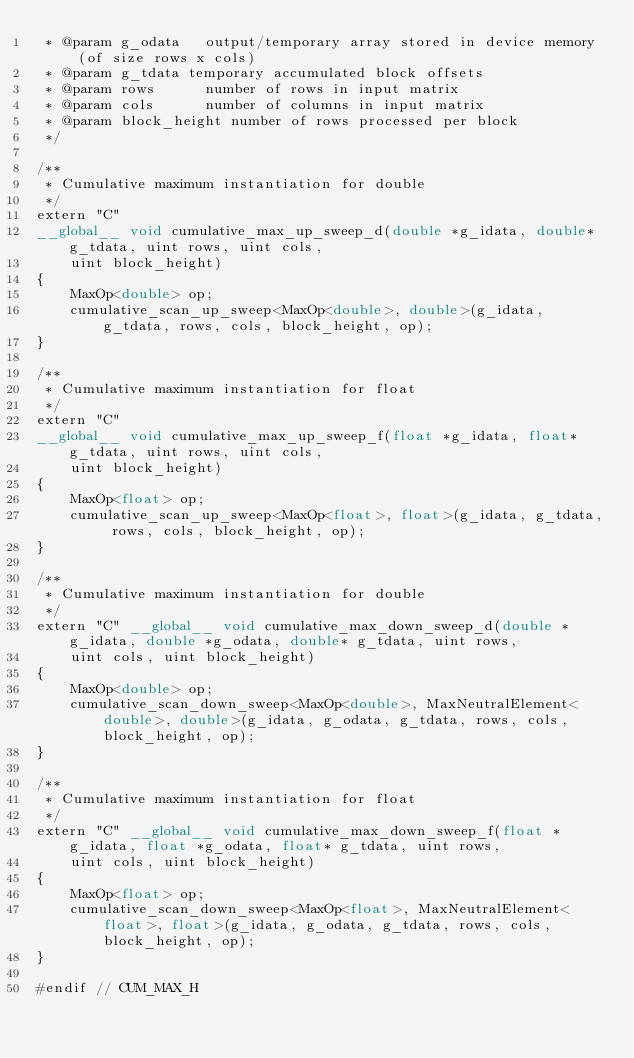Convert code to text. <code><loc_0><loc_0><loc_500><loc_500><_Cuda_> * @param g_odata   output/temporary array stored in device memory (of size rows x cols)
 * @param g_tdata temporary accumulated block offsets
 * @param rows      number of rows in input matrix
 * @param cols      number of columns in input matrix
 * @param block_height number of rows processed per block
 */

/**
 * Cumulative maximum instantiation for double
 */
extern "C"
__global__ void cumulative_max_up_sweep_d(double *g_idata, double* g_tdata, uint rows, uint cols,
    uint block_height)
{
	MaxOp<double> op;
	cumulative_scan_up_sweep<MaxOp<double>, double>(g_idata, g_tdata, rows, cols, block_height, op);
}

/**
 * Cumulative maximum instantiation for float
 */
extern "C"
__global__ void cumulative_max_up_sweep_f(float *g_idata, float* g_tdata, uint rows, uint cols,
    uint block_height)
{
	MaxOp<float> op;
	cumulative_scan_up_sweep<MaxOp<float>, float>(g_idata, g_tdata, rows, cols, block_height, op);
}

/**
 * Cumulative maximum instantiation for double
 */
extern "C" __global__ void cumulative_max_down_sweep_d(double *g_idata, double *g_odata, double* g_tdata, uint rows,
    uint cols, uint block_height)
{
	MaxOp<double> op;
	cumulative_scan_down_sweep<MaxOp<double>, MaxNeutralElement<double>, double>(g_idata, g_odata, g_tdata, rows, cols, block_height, op);
}

/**
 * Cumulative maximum instantiation for float
 */
extern "C" __global__ void cumulative_max_down_sweep_f(float *g_idata, float *g_odata, float* g_tdata, uint rows,
    uint cols, uint block_height)
{
	MaxOp<float> op;
	cumulative_scan_down_sweep<MaxOp<float>, MaxNeutralElement<float>, float>(g_idata, g_odata, g_tdata, rows, cols, block_height, op);
}

#endif // CUM_MAX_H
</code> 